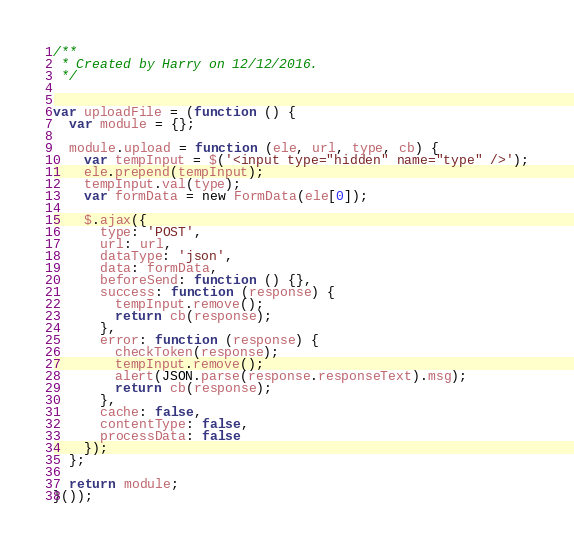<code> <loc_0><loc_0><loc_500><loc_500><_JavaScript_>/**
 * Created by Harry on 12/12/2016.
 */


var uploadFile = (function () {
  var module = {};

  module.upload = function (ele, url, type, cb) {
    var tempInput = $('<input type="hidden" name="type" />');
    ele.prepend(tempInput);
    tempInput.val(type);
    var formData = new FormData(ele[0]);

    $.ajax({
      type: 'POST',
      url: url,
      dataType: 'json',
      data: formData,
      beforeSend: function () {},
      success: function (response) {
        tempInput.remove();
        return cb(response);
      },
      error: function (response) {
        checkToken(response);
        tempInput.remove();
        alert(JSON.parse(response.responseText).msg);
        return cb(response);
      },
      cache: false,
      contentType: false,
      processData: false
    });
  };

  return module;
}());
</code> 